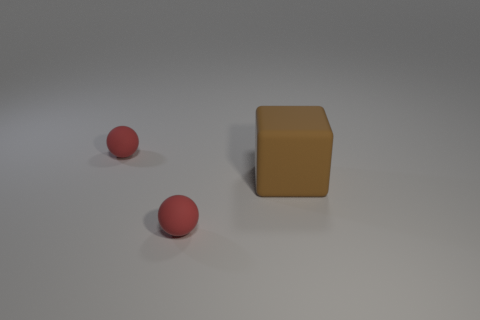Are there more purple things than brown objects?
Keep it short and to the point. No. Does the red ball that is behind the large brown matte cube have the same size as the rubber sphere in front of the big brown object?
Give a very brief answer. Yes. What number of things are either tiny matte spheres in front of the block or large green metal cylinders?
Your answer should be very brief. 1. Are there fewer large brown cylinders than big brown rubber cubes?
Give a very brief answer. Yes. The brown matte object on the right side of the red matte ball that is in front of the red matte ball that is behind the large brown matte block is what shape?
Your answer should be compact. Cube. Is there a red thing?
Give a very brief answer. Yes. There is a matte cube; is its size the same as the sphere that is behind the block?
Give a very brief answer. No. There is a tiny rubber object that is behind the rubber block; are there any tiny matte balls right of it?
Keep it short and to the point. Yes. What color is the small ball to the right of the small red object behind the matte ball in front of the big brown rubber thing?
Give a very brief answer. Red. Does the block have the same color as the rubber sphere in front of the rubber block?
Keep it short and to the point. No. 